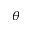<formula> <loc_0><loc_0><loc_500><loc_500>\theta</formula> 